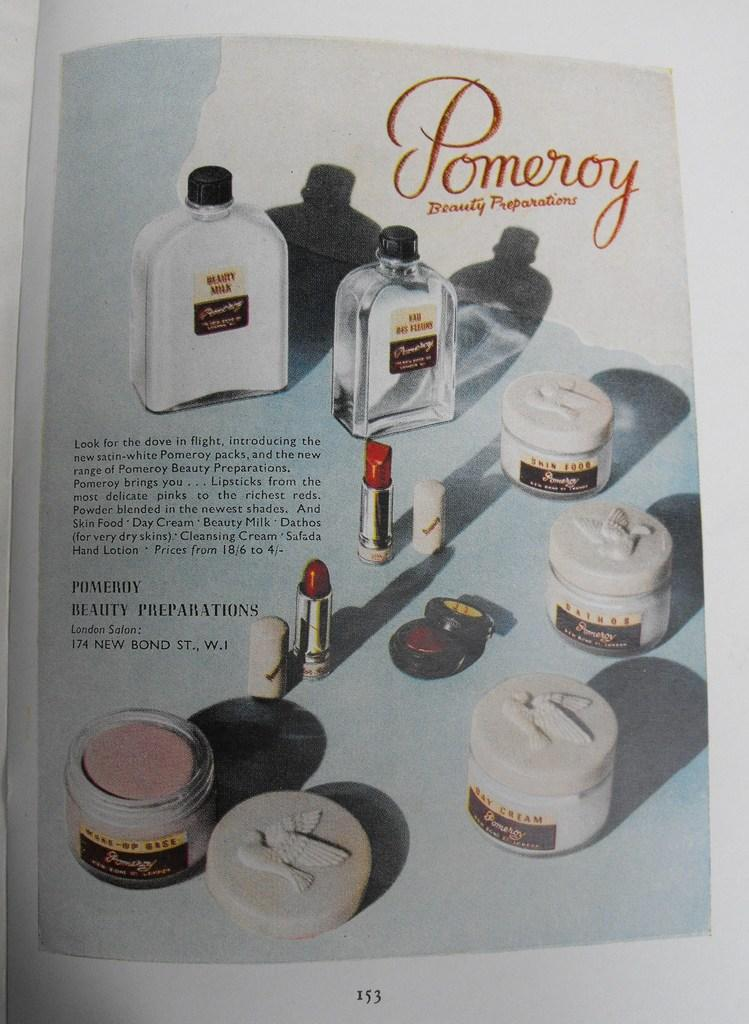<image>
Render a clear and concise summary of the photo. A magazine ad for Pomeroy features many beauty products. 